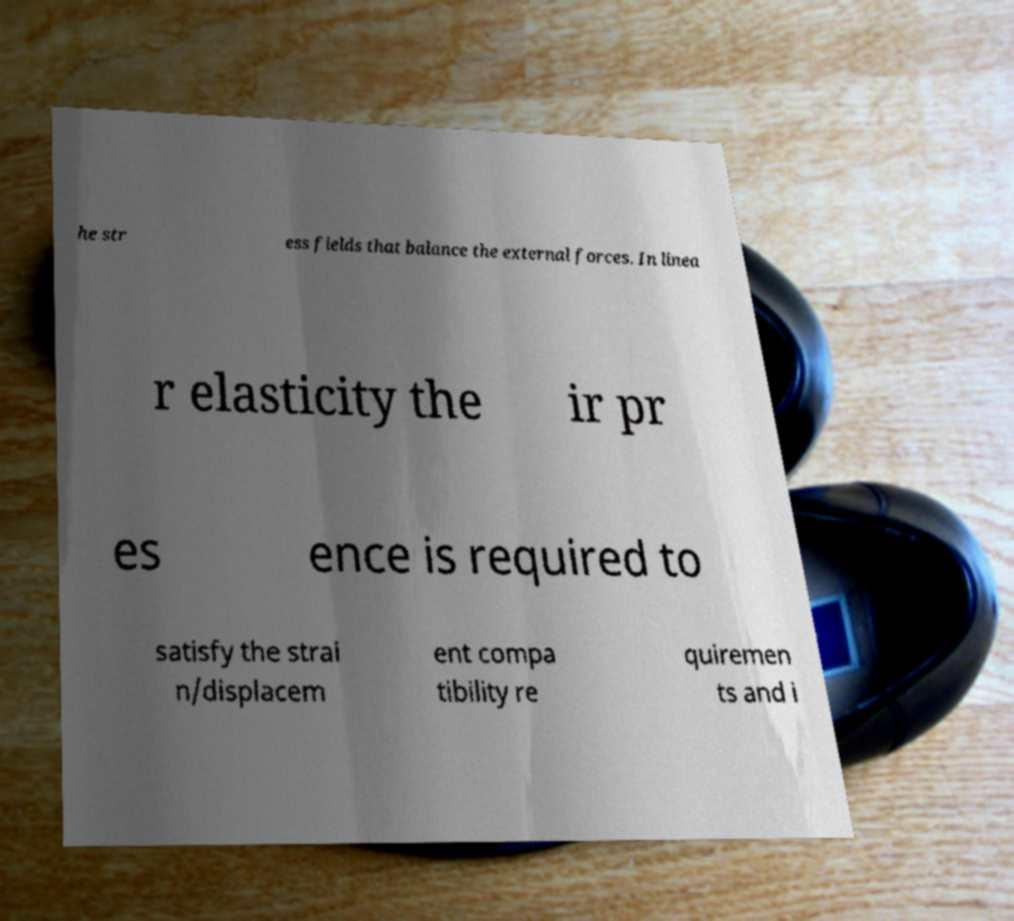What messages or text are displayed in this image? I need them in a readable, typed format. he str ess fields that balance the external forces. In linea r elasticity the ir pr es ence is required to satisfy the strai n/displacem ent compa tibility re quiremen ts and i 